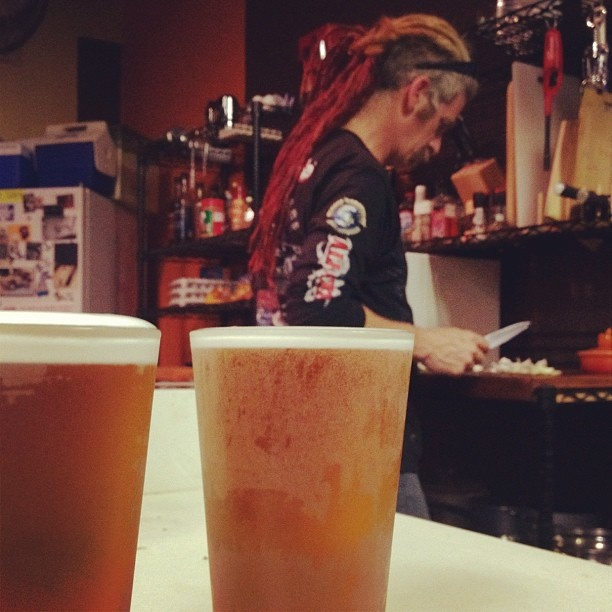Describe the objects in this image and their specific colors. I can see cup in black, brown, tan, and beige tones, people in black, maroon, and brown tones, cup in black, maroon, brown, and beige tones, refrigerator in black, brown, maroon, and tan tones, and bowl in black, brown, and maroon tones in this image. 